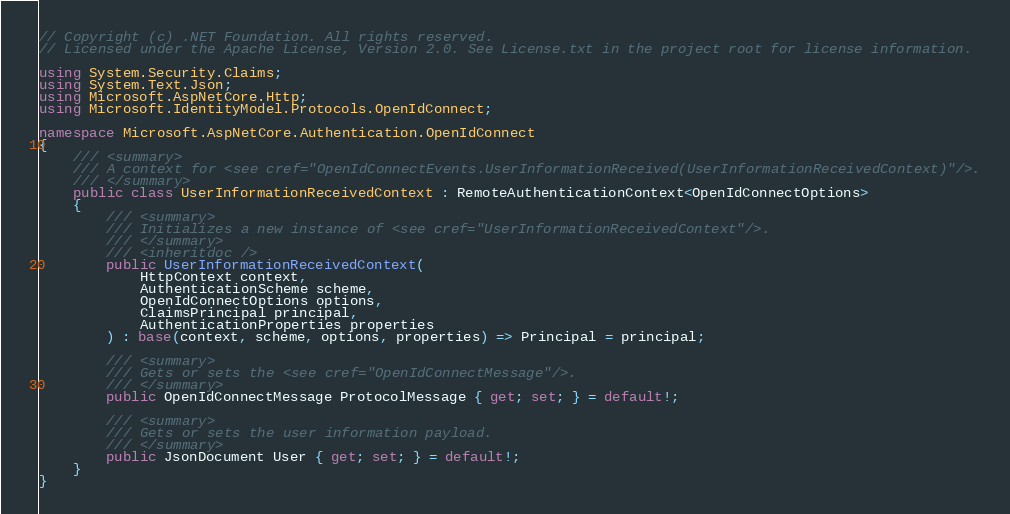Convert code to text. <code><loc_0><loc_0><loc_500><loc_500><_C#_>// Copyright (c) .NET Foundation. All rights reserved.
// Licensed under the Apache License, Version 2.0. See License.txt in the project root for license information.

using System.Security.Claims;
using System.Text.Json;
using Microsoft.AspNetCore.Http;
using Microsoft.IdentityModel.Protocols.OpenIdConnect;

namespace Microsoft.AspNetCore.Authentication.OpenIdConnect
{
    /// <summary>
    /// A context for <see cref="OpenIdConnectEvents.UserInformationReceived(UserInformationReceivedContext)"/>.
    /// </summary>
    public class UserInformationReceivedContext : RemoteAuthenticationContext<OpenIdConnectOptions>
    {
        /// <summary>
        /// Initializes a new instance of <see cref="UserInformationReceivedContext"/>.
        /// </summary>
        /// <inheritdoc />
        public UserInformationReceivedContext(
            HttpContext context,
            AuthenticationScheme scheme,
            OpenIdConnectOptions options,
            ClaimsPrincipal principal,
            AuthenticationProperties properties
        ) : base(context, scheme, options, properties) => Principal = principal;

        /// <summary>
        /// Gets or sets the <see cref="OpenIdConnectMessage"/>.
        /// </summary>
        public OpenIdConnectMessage ProtocolMessage { get; set; } = default!;

        /// <summary>
        /// Gets or sets the user information payload.
        /// </summary>
        public JsonDocument User { get; set; } = default!;
    }
}
</code> 